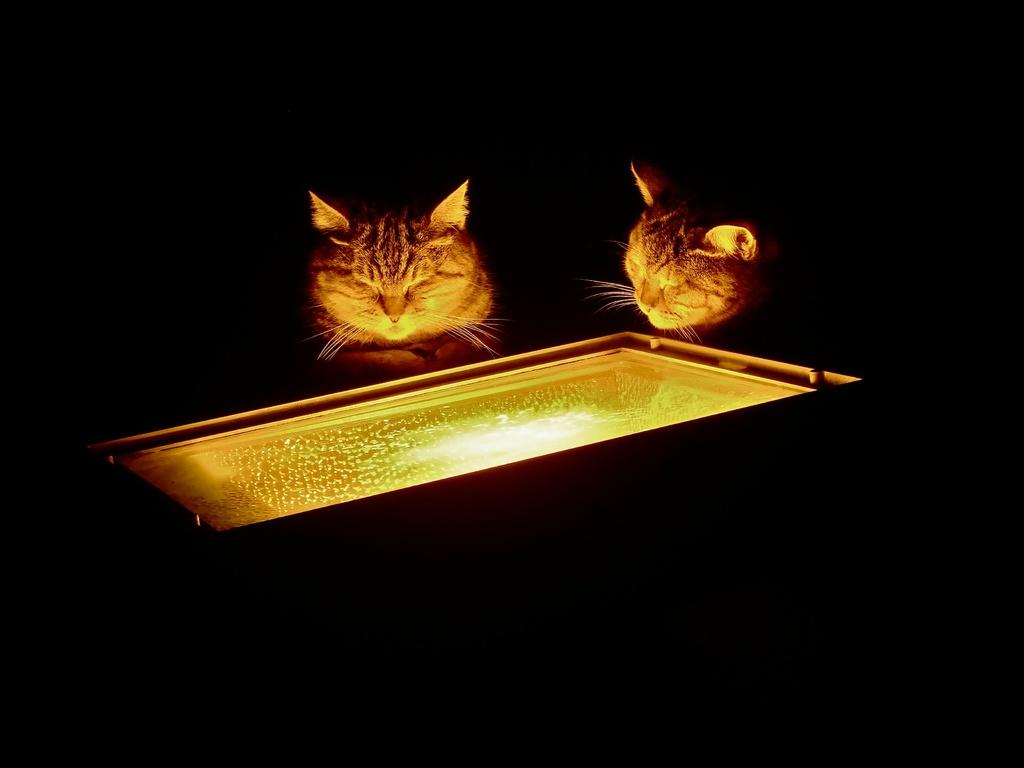How many cats are present in the image? There are two cats in the image. What are the cats doing in the image? The cats are looking into an object. Can you describe the object the cats are looking into? There is light visible in the object. What is the color of the background in the image? The background of the image is dark. What is the price of the kettle in the image? There is no kettle present in the image; it features two cats looking into an object with light visible inside. How many cattle can be seen in the image? There are no cattle present in the image; it features two cats looking into an object with light visible inside. 